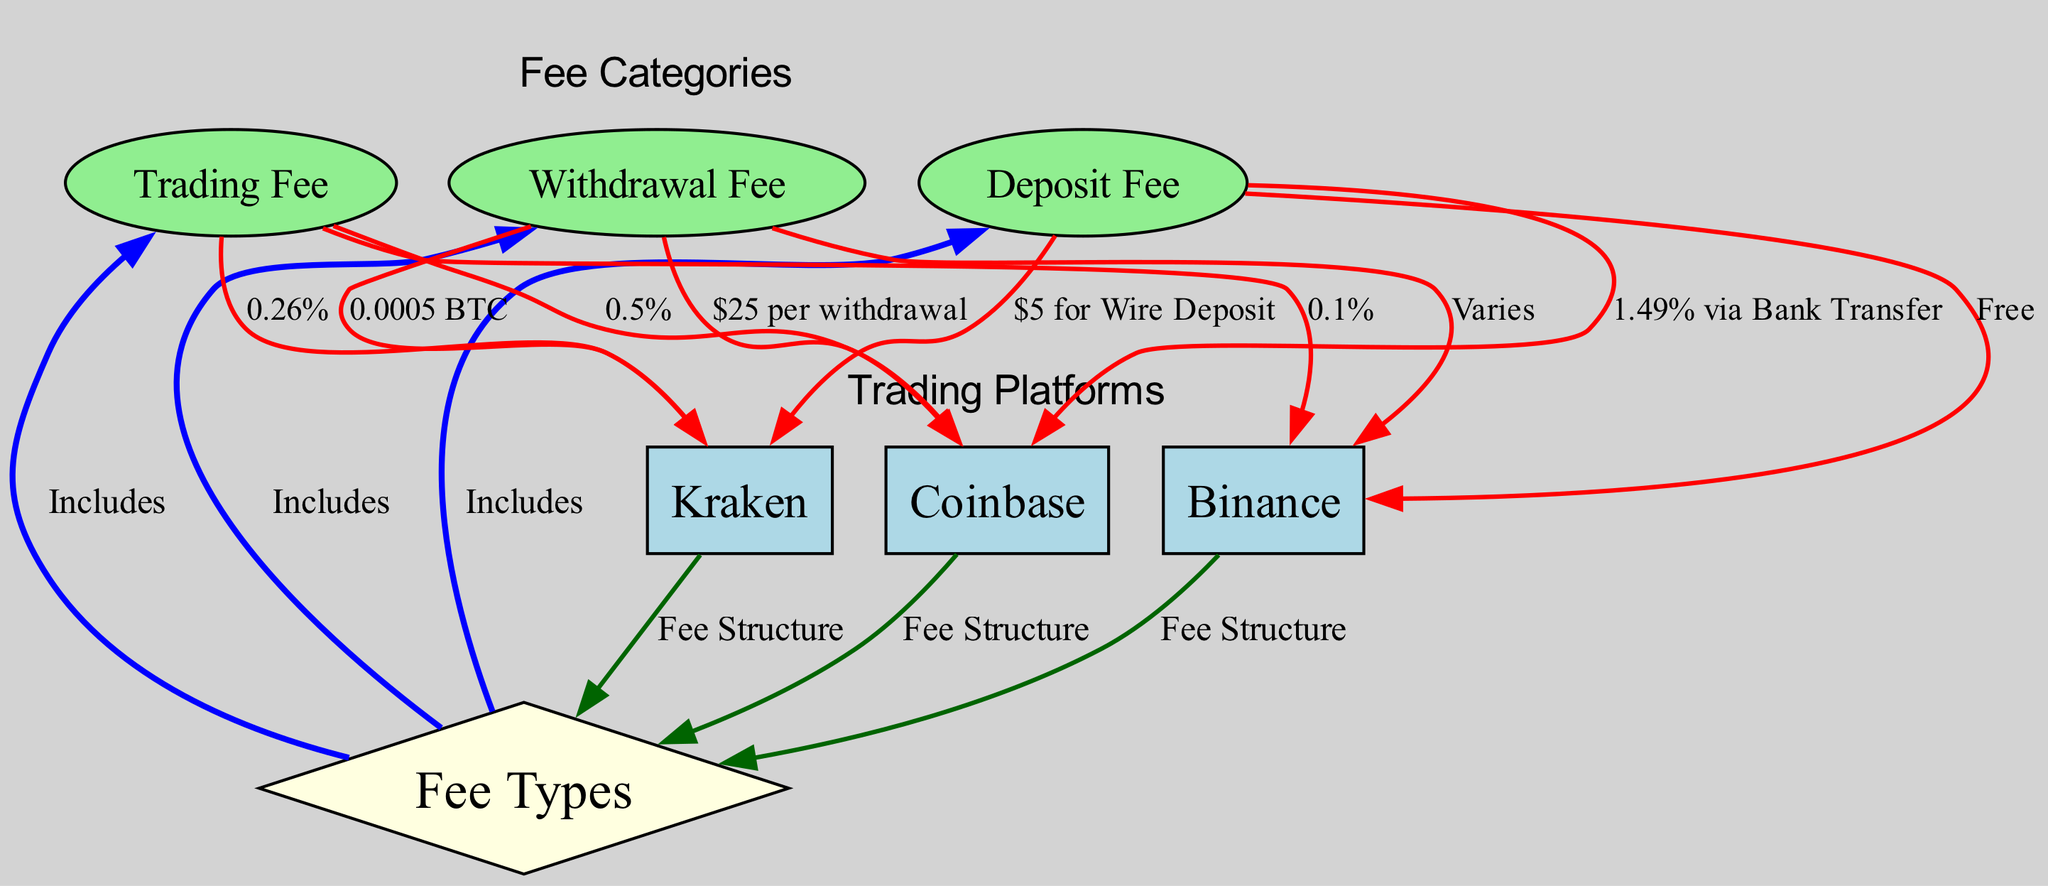What is the trading fee percentage for Binance? The diagram indicates that the trading fee for Binance is connected to the 'trading fee' node with an edge labeled '0.1%'. Thus, the trading fee percentage for Binance is 0.1%.
Answer: 0.1% What is the deposit fee percentage for Coinbase? Following the flow from the 'deposit_fee' node to Coinbase, the edge is labeled '1.49% via Bank Transfer'. Hence, the deposit fee percentage for Coinbase is 1.49%.
Answer: 1.49% How many platforms are listed within the diagram? By counting the nodes labeled as platforms (Binance, Coinbase, Kraken), there are three distinct platform nodes present in the diagram.
Answer: 3 What is the withdrawal fee for Kraken? The edge connecting the 'withdrawal_fee' node to Kraken is labeled '0.0005 BTC'. This indicates that the withdrawal fee for Kraken is 0.0005 BTC.
Answer: 0.0005 BTC Which platform has the highest trading fee? Comparing the trading fees shown: Binance at 0.1%, Coinbase at 0.5%, and Kraken at 0.26%, Coinbase has the highest trading fee at 0.5%.
Answer: Coinbase Is there a deposit fee for Binance? The diagram indicates that the edge from the 'deposit_fee' node to Binance is labeled 'Free', confirming that there is no deposit fee for Binance.
Answer: Free What type of fee does Kraken have for deposits? The edge from the 'deposit_fee' node to Kraken is labeled '$5 for Wire Deposit', showing that Kraken has a $5 fee for deposits via wire transfer.
Answer: $5 for Wire Deposit Which fee type is included for all platforms? The 'fee_types' node is connected via edges to the 'trading_fee', 'withdrawal_fee', and 'deposit_fee'. Hence, all platforms include a trading fee, withdrawal fee, and deposit fee.
Answer: Trading Fee, Withdrawal Fee, Deposit Fee What is the label of the relationship between platforms and fee types? All platforms have edges connecting to 'fee_types' labeled 'Fee Structure', representing their connection to the fee types mentioned.
Answer: Fee Structure 